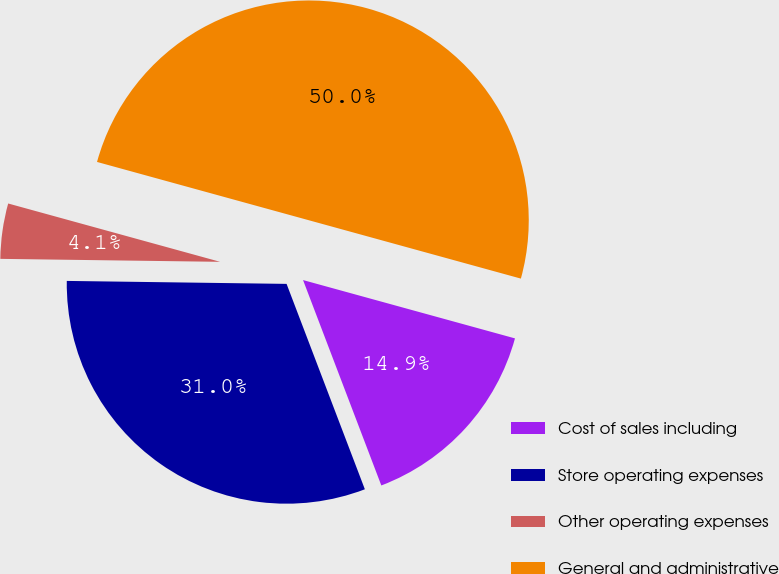<chart> <loc_0><loc_0><loc_500><loc_500><pie_chart><fcel>Cost of sales including<fcel>Store operating expenses<fcel>Other operating expenses<fcel>General and administrative<nl><fcel>14.93%<fcel>31.01%<fcel>4.06%<fcel>50.0%<nl></chart> 